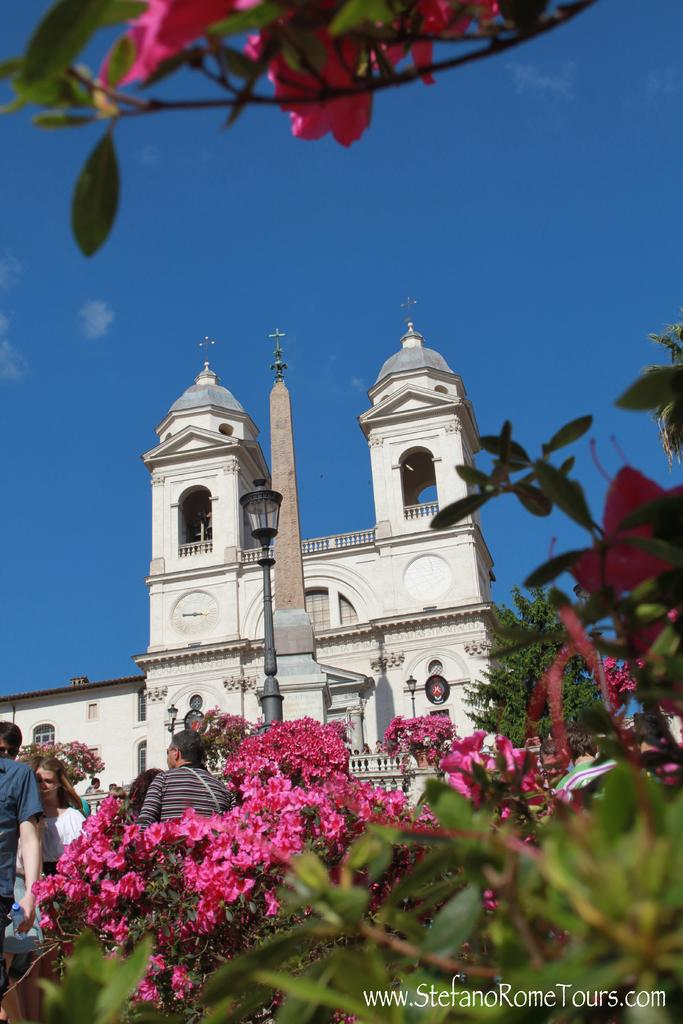What type of plants can be seen in the image? There are plants with flowers in the image. Can you describe the people in the image? There is a group of people standing in the image. What structures are present in the image? There are poles and a building in the image. What is the source of illumination in the image? There are lights in the image. What type of vegetation is visible in the image? There is a tree in the image. What part of the natural environment is visible in the image? The sky is visible in the image. What type of pickle is being used to measure the height of the building in the image? There is no pickle present in the image, and the height of the building is not being measured. 